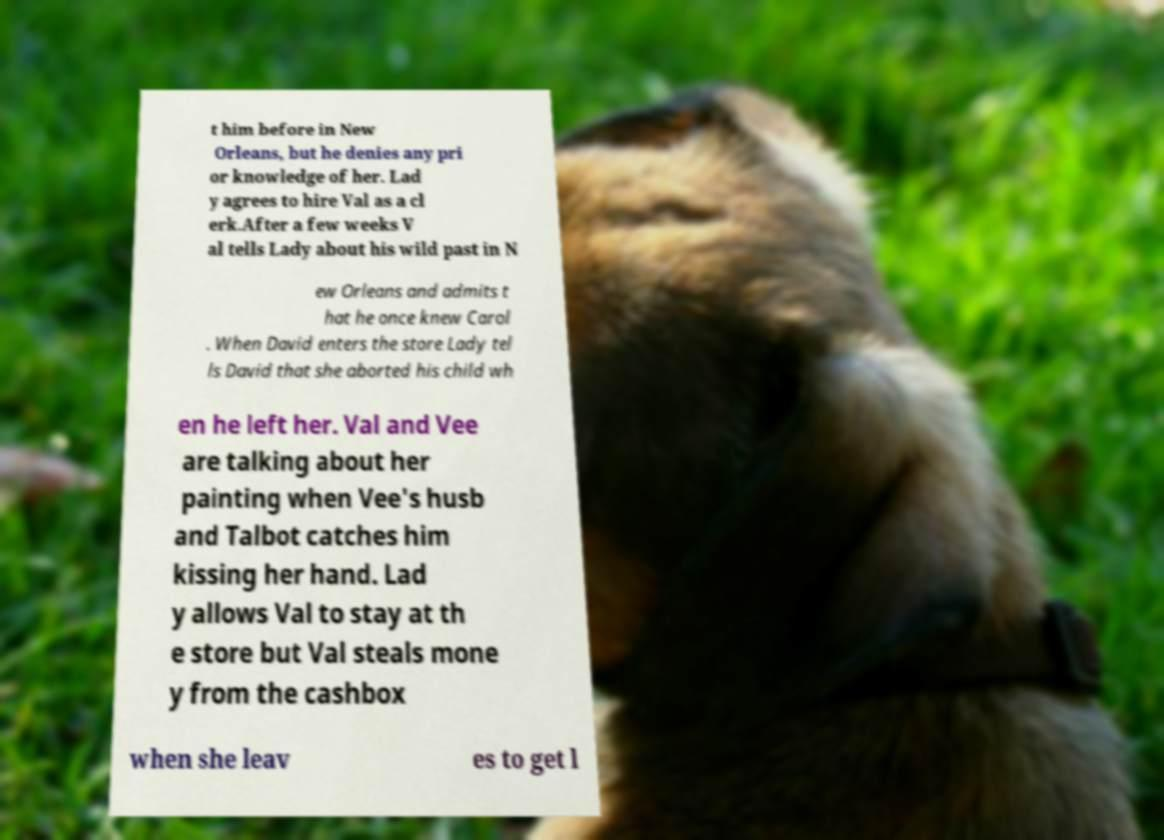I need the written content from this picture converted into text. Can you do that? t him before in New Orleans, but he denies any pri or knowledge of her. Lad y agrees to hire Val as a cl erk.After a few weeks V al tells Lady about his wild past in N ew Orleans and admits t hat he once knew Carol . When David enters the store Lady tel ls David that she aborted his child wh en he left her. Val and Vee are talking about her painting when Vee's husb and Talbot catches him kissing her hand. Lad y allows Val to stay at th e store but Val steals mone y from the cashbox when she leav es to get l 